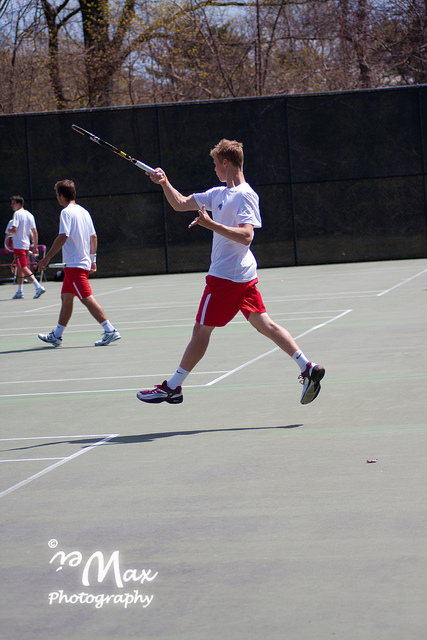Read and extract the text from this image. Max Photography 